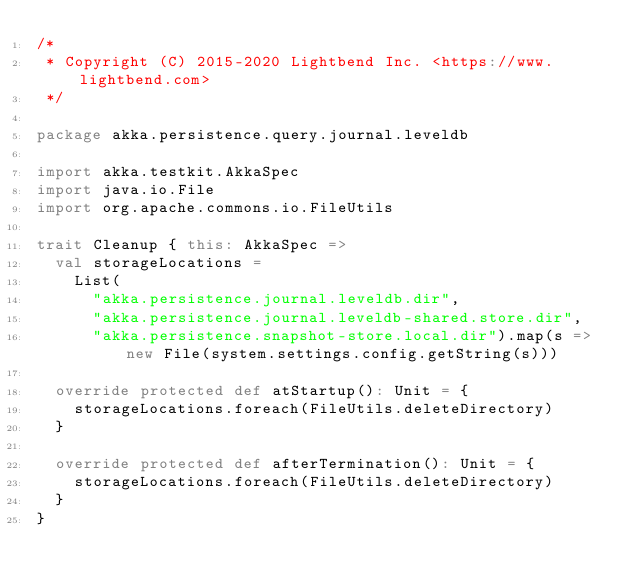Convert code to text. <code><loc_0><loc_0><loc_500><loc_500><_Scala_>/*
 * Copyright (C) 2015-2020 Lightbend Inc. <https://www.lightbend.com>
 */

package akka.persistence.query.journal.leveldb

import akka.testkit.AkkaSpec
import java.io.File
import org.apache.commons.io.FileUtils

trait Cleanup { this: AkkaSpec =>
  val storageLocations =
    List(
      "akka.persistence.journal.leveldb.dir",
      "akka.persistence.journal.leveldb-shared.store.dir",
      "akka.persistence.snapshot-store.local.dir").map(s => new File(system.settings.config.getString(s)))

  override protected def atStartup(): Unit = {
    storageLocations.foreach(FileUtils.deleteDirectory)
  }

  override protected def afterTermination(): Unit = {
    storageLocations.foreach(FileUtils.deleteDirectory)
  }
}
</code> 